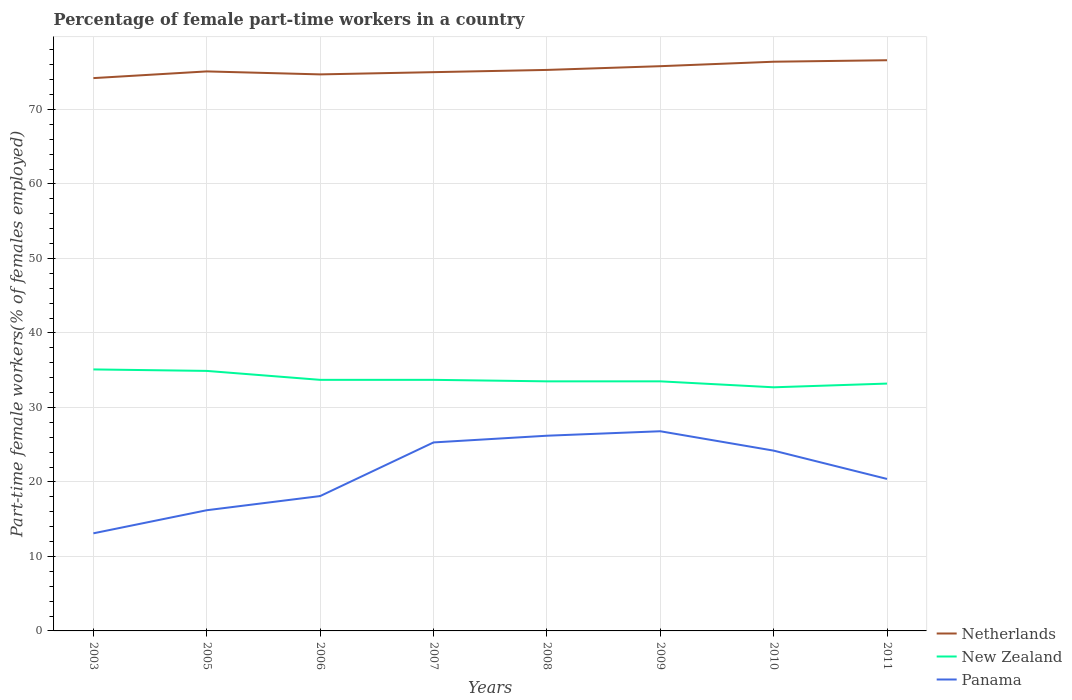Does the line corresponding to Panama intersect with the line corresponding to New Zealand?
Your answer should be very brief. No. Across all years, what is the maximum percentage of female part-time workers in New Zealand?
Keep it short and to the point. 32.7. What is the difference between the highest and the second highest percentage of female part-time workers in Netherlands?
Keep it short and to the point. 2.4. What is the difference between the highest and the lowest percentage of female part-time workers in Panama?
Make the answer very short. 4. Is the percentage of female part-time workers in New Zealand strictly greater than the percentage of female part-time workers in Netherlands over the years?
Offer a very short reply. Yes. How many lines are there?
Your answer should be very brief. 3. How many years are there in the graph?
Keep it short and to the point. 8. What is the difference between two consecutive major ticks on the Y-axis?
Offer a terse response. 10. Are the values on the major ticks of Y-axis written in scientific E-notation?
Your response must be concise. No. Where does the legend appear in the graph?
Your response must be concise. Bottom right. How many legend labels are there?
Offer a terse response. 3. How are the legend labels stacked?
Ensure brevity in your answer.  Vertical. What is the title of the graph?
Give a very brief answer. Percentage of female part-time workers in a country. Does "Myanmar" appear as one of the legend labels in the graph?
Provide a succinct answer. No. What is the label or title of the X-axis?
Provide a short and direct response. Years. What is the label or title of the Y-axis?
Keep it short and to the point. Part-time female workers(% of females employed). What is the Part-time female workers(% of females employed) of Netherlands in 2003?
Give a very brief answer. 74.2. What is the Part-time female workers(% of females employed) in New Zealand in 2003?
Offer a very short reply. 35.1. What is the Part-time female workers(% of females employed) in Panama in 2003?
Provide a short and direct response. 13.1. What is the Part-time female workers(% of females employed) in Netherlands in 2005?
Give a very brief answer. 75.1. What is the Part-time female workers(% of females employed) of New Zealand in 2005?
Make the answer very short. 34.9. What is the Part-time female workers(% of females employed) in Panama in 2005?
Your answer should be compact. 16.2. What is the Part-time female workers(% of females employed) of Netherlands in 2006?
Your response must be concise. 74.7. What is the Part-time female workers(% of females employed) of New Zealand in 2006?
Keep it short and to the point. 33.7. What is the Part-time female workers(% of females employed) in Panama in 2006?
Give a very brief answer. 18.1. What is the Part-time female workers(% of females employed) of New Zealand in 2007?
Ensure brevity in your answer.  33.7. What is the Part-time female workers(% of females employed) of Panama in 2007?
Provide a succinct answer. 25.3. What is the Part-time female workers(% of females employed) in Netherlands in 2008?
Keep it short and to the point. 75.3. What is the Part-time female workers(% of females employed) of New Zealand in 2008?
Give a very brief answer. 33.5. What is the Part-time female workers(% of females employed) of Panama in 2008?
Your answer should be compact. 26.2. What is the Part-time female workers(% of females employed) of Netherlands in 2009?
Offer a terse response. 75.8. What is the Part-time female workers(% of females employed) of New Zealand in 2009?
Provide a succinct answer. 33.5. What is the Part-time female workers(% of females employed) in Panama in 2009?
Make the answer very short. 26.8. What is the Part-time female workers(% of females employed) in Netherlands in 2010?
Offer a terse response. 76.4. What is the Part-time female workers(% of females employed) in New Zealand in 2010?
Your answer should be very brief. 32.7. What is the Part-time female workers(% of females employed) of Panama in 2010?
Provide a succinct answer. 24.2. What is the Part-time female workers(% of females employed) in Netherlands in 2011?
Ensure brevity in your answer.  76.6. What is the Part-time female workers(% of females employed) of New Zealand in 2011?
Keep it short and to the point. 33.2. What is the Part-time female workers(% of females employed) in Panama in 2011?
Provide a succinct answer. 20.4. Across all years, what is the maximum Part-time female workers(% of females employed) of Netherlands?
Your answer should be compact. 76.6. Across all years, what is the maximum Part-time female workers(% of females employed) of New Zealand?
Make the answer very short. 35.1. Across all years, what is the maximum Part-time female workers(% of females employed) in Panama?
Offer a terse response. 26.8. Across all years, what is the minimum Part-time female workers(% of females employed) of Netherlands?
Offer a very short reply. 74.2. Across all years, what is the minimum Part-time female workers(% of females employed) of New Zealand?
Your answer should be very brief. 32.7. Across all years, what is the minimum Part-time female workers(% of females employed) in Panama?
Provide a succinct answer. 13.1. What is the total Part-time female workers(% of females employed) in Netherlands in the graph?
Ensure brevity in your answer.  603.1. What is the total Part-time female workers(% of females employed) in New Zealand in the graph?
Provide a succinct answer. 270.3. What is the total Part-time female workers(% of females employed) in Panama in the graph?
Ensure brevity in your answer.  170.3. What is the difference between the Part-time female workers(% of females employed) of Netherlands in 2003 and that in 2005?
Your answer should be very brief. -0.9. What is the difference between the Part-time female workers(% of females employed) in New Zealand in 2003 and that in 2005?
Your answer should be compact. 0.2. What is the difference between the Part-time female workers(% of females employed) of Panama in 2003 and that in 2005?
Your response must be concise. -3.1. What is the difference between the Part-time female workers(% of females employed) in Panama in 2003 and that in 2006?
Keep it short and to the point. -5. What is the difference between the Part-time female workers(% of females employed) of Netherlands in 2003 and that in 2007?
Provide a short and direct response. -0.8. What is the difference between the Part-time female workers(% of females employed) in New Zealand in 2003 and that in 2007?
Offer a very short reply. 1.4. What is the difference between the Part-time female workers(% of females employed) in Panama in 2003 and that in 2008?
Keep it short and to the point. -13.1. What is the difference between the Part-time female workers(% of females employed) of Netherlands in 2003 and that in 2009?
Keep it short and to the point. -1.6. What is the difference between the Part-time female workers(% of females employed) in New Zealand in 2003 and that in 2009?
Your answer should be compact. 1.6. What is the difference between the Part-time female workers(% of females employed) in Panama in 2003 and that in 2009?
Your response must be concise. -13.7. What is the difference between the Part-time female workers(% of females employed) of Netherlands in 2003 and that in 2010?
Give a very brief answer. -2.2. What is the difference between the Part-time female workers(% of females employed) in New Zealand in 2003 and that in 2010?
Keep it short and to the point. 2.4. What is the difference between the Part-time female workers(% of females employed) of New Zealand in 2003 and that in 2011?
Give a very brief answer. 1.9. What is the difference between the Part-time female workers(% of females employed) in Panama in 2003 and that in 2011?
Keep it short and to the point. -7.3. What is the difference between the Part-time female workers(% of females employed) in Netherlands in 2005 and that in 2007?
Offer a very short reply. 0.1. What is the difference between the Part-time female workers(% of females employed) in Panama in 2005 and that in 2007?
Offer a very short reply. -9.1. What is the difference between the Part-time female workers(% of females employed) in New Zealand in 2005 and that in 2008?
Offer a very short reply. 1.4. What is the difference between the Part-time female workers(% of females employed) of Panama in 2005 and that in 2008?
Make the answer very short. -10. What is the difference between the Part-time female workers(% of females employed) in Netherlands in 2005 and that in 2009?
Make the answer very short. -0.7. What is the difference between the Part-time female workers(% of females employed) in Panama in 2005 and that in 2009?
Ensure brevity in your answer.  -10.6. What is the difference between the Part-time female workers(% of females employed) of New Zealand in 2005 and that in 2010?
Your answer should be very brief. 2.2. What is the difference between the Part-time female workers(% of females employed) of Panama in 2005 and that in 2010?
Offer a terse response. -8. What is the difference between the Part-time female workers(% of females employed) in Netherlands in 2005 and that in 2011?
Make the answer very short. -1.5. What is the difference between the Part-time female workers(% of females employed) in Panama in 2005 and that in 2011?
Make the answer very short. -4.2. What is the difference between the Part-time female workers(% of females employed) of Netherlands in 2006 and that in 2007?
Ensure brevity in your answer.  -0.3. What is the difference between the Part-time female workers(% of females employed) in New Zealand in 2006 and that in 2008?
Ensure brevity in your answer.  0.2. What is the difference between the Part-time female workers(% of females employed) in Panama in 2006 and that in 2009?
Give a very brief answer. -8.7. What is the difference between the Part-time female workers(% of females employed) of Panama in 2006 and that in 2010?
Your answer should be very brief. -6.1. What is the difference between the Part-time female workers(% of females employed) in Netherlands in 2006 and that in 2011?
Your answer should be compact. -1.9. What is the difference between the Part-time female workers(% of females employed) in New Zealand in 2006 and that in 2011?
Your answer should be compact. 0.5. What is the difference between the Part-time female workers(% of females employed) in Panama in 2006 and that in 2011?
Ensure brevity in your answer.  -2.3. What is the difference between the Part-time female workers(% of females employed) of Netherlands in 2007 and that in 2008?
Give a very brief answer. -0.3. What is the difference between the Part-time female workers(% of females employed) of Panama in 2007 and that in 2008?
Offer a terse response. -0.9. What is the difference between the Part-time female workers(% of females employed) of New Zealand in 2007 and that in 2009?
Offer a terse response. 0.2. What is the difference between the Part-time female workers(% of females employed) of Netherlands in 2007 and that in 2010?
Your answer should be compact. -1.4. What is the difference between the Part-time female workers(% of females employed) of Netherlands in 2008 and that in 2009?
Give a very brief answer. -0.5. What is the difference between the Part-time female workers(% of females employed) of New Zealand in 2008 and that in 2010?
Your answer should be compact. 0.8. What is the difference between the Part-time female workers(% of females employed) of Panama in 2008 and that in 2010?
Give a very brief answer. 2. What is the difference between the Part-time female workers(% of females employed) of Netherlands in 2008 and that in 2011?
Provide a succinct answer. -1.3. What is the difference between the Part-time female workers(% of females employed) in New Zealand in 2008 and that in 2011?
Keep it short and to the point. 0.3. What is the difference between the Part-time female workers(% of females employed) in New Zealand in 2009 and that in 2010?
Ensure brevity in your answer.  0.8. What is the difference between the Part-time female workers(% of females employed) in Panama in 2009 and that in 2010?
Give a very brief answer. 2.6. What is the difference between the Part-time female workers(% of females employed) in Netherlands in 2009 and that in 2011?
Provide a short and direct response. -0.8. What is the difference between the Part-time female workers(% of females employed) of Panama in 2009 and that in 2011?
Your answer should be very brief. 6.4. What is the difference between the Part-time female workers(% of females employed) of Netherlands in 2010 and that in 2011?
Provide a succinct answer. -0.2. What is the difference between the Part-time female workers(% of females employed) in New Zealand in 2010 and that in 2011?
Your answer should be compact. -0.5. What is the difference between the Part-time female workers(% of females employed) in Panama in 2010 and that in 2011?
Provide a succinct answer. 3.8. What is the difference between the Part-time female workers(% of females employed) in Netherlands in 2003 and the Part-time female workers(% of females employed) in New Zealand in 2005?
Ensure brevity in your answer.  39.3. What is the difference between the Part-time female workers(% of females employed) of Netherlands in 2003 and the Part-time female workers(% of females employed) of Panama in 2005?
Provide a succinct answer. 58. What is the difference between the Part-time female workers(% of females employed) in New Zealand in 2003 and the Part-time female workers(% of females employed) in Panama in 2005?
Provide a short and direct response. 18.9. What is the difference between the Part-time female workers(% of females employed) in Netherlands in 2003 and the Part-time female workers(% of females employed) in New Zealand in 2006?
Your answer should be compact. 40.5. What is the difference between the Part-time female workers(% of females employed) in Netherlands in 2003 and the Part-time female workers(% of females employed) in Panama in 2006?
Keep it short and to the point. 56.1. What is the difference between the Part-time female workers(% of females employed) in Netherlands in 2003 and the Part-time female workers(% of females employed) in New Zealand in 2007?
Your answer should be very brief. 40.5. What is the difference between the Part-time female workers(% of females employed) in Netherlands in 2003 and the Part-time female workers(% of females employed) in Panama in 2007?
Ensure brevity in your answer.  48.9. What is the difference between the Part-time female workers(% of females employed) of Netherlands in 2003 and the Part-time female workers(% of females employed) of New Zealand in 2008?
Keep it short and to the point. 40.7. What is the difference between the Part-time female workers(% of females employed) in Netherlands in 2003 and the Part-time female workers(% of females employed) in Panama in 2008?
Your answer should be compact. 48. What is the difference between the Part-time female workers(% of females employed) of Netherlands in 2003 and the Part-time female workers(% of females employed) of New Zealand in 2009?
Keep it short and to the point. 40.7. What is the difference between the Part-time female workers(% of females employed) in Netherlands in 2003 and the Part-time female workers(% of females employed) in Panama in 2009?
Give a very brief answer. 47.4. What is the difference between the Part-time female workers(% of females employed) of New Zealand in 2003 and the Part-time female workers(% of females employed) of Panama in 2009?
Your answer should be compact. 8.3. What is the difference between the Part-time female workers(% of females employed) in Netherlands in 2003 and the Part-time female workers(% of females employed) in New Zealand in 2010?
Offer a terse response. 41.5. What is the difference between the Part-time female workers(% of females employed) in Netherlands in 2003 and the Part-time female workers(% of females employed) in Panama in 2011?
Provide a succinct answer. 53.8. What is the difference between the Part-time female workers(% of females employed) in New Zealand in 2003 and the Part-time female workers(% of females employed) in Panama in 2011?
Provide a succinct answer. 14.7. What is the difference between the Part-time female workers(% of females employed) of Netherlands in 2005 and the Part-time female workers(% of females employed) of New Zealand in 2006?
Give a very brief answer. 41.4. What is the difference between the Part-time female workers(% of females employed) of Netherlands in 2005 and the Part-time female workers(% of females employed) of New Zealand in 2007?
Ensure brevity in your answer.  41.4. What is the difference between the Part-time female workers(% of females employed) of Netherlands in 2005 and the Part-time female workers(% of females employed) of Panama in 2007?
Your response must be concise. 49.8. What is the difference between the Part-time female workers(% of females employed) in Netherlands in 2005 and the Part-time female workers(% of females employed) in New Zealand in 2008?
Offer a very short reply. 41.6. What is the difference between the Part-time female workers(% of females employed) in Netherlands in 2005 and the Part-time female workers(% of females employed) in Panama in 2008?
Give a very brief answer. 48.9. What is the difference between the Part-time female workers(% of females employed) of New Zealand in 2005 and the Part-time female workers(% of females employed) of Panama in 2008?
Ensure brevity in your answer.  8.7. What is the difference between the Part-time female workers(% of females employed) of Netherlands in 2005 and the Part-time female workers(% of females employed) of New Zealand in 2009?
Provide a succinct answer. 41.6. What is the difference between the Part-time female workers(% of females employed) in Netherlands in 2005 and the Part-time female workers(% of females employed) in Panama in 2009?
Make the answer very short. 48.3. What is the difference between the Part-time female workers(% of females employed) in New Zealand in 2005 and the Part-time female workers(% of females employed) in Panama in 2009?
Provide a short and direct response. 8.1. What is the difference between the Part-time female workers(% of females employed) of Netherlands in 2005 and the Part-time female workers(% of females employed) of New Zealand in 2010?
Your answer should be very brief. 42.4. What is the difference between the Part-time female workers(% of females employed) in Netherlands in 2005 and the Part-time female workers(% of females employed) in Panama in 2010?
Make the answer very short. 50.9. What is the difference between the Part-time female workers(% of females employed) of New Zealand in 2005 and the Part-time female workers(% of females employed) of Panama in 2010?
Keep it short and to the point. 10.7. What is the difference between the Part-time female workers(% of females employed) in Netherlands in 2005 and the Part-time female workers(% of females employed) in New Zealand in 2011?
Keep it short and to the point. 41.9. What is the difference between the Part-time female workers(% of females employed) of Netherlands in 2005 and the Part-time female workers(% of females employed) of Panama in 2011?
Your answer should be very brief. 54.7. What is the difference between the Part-time female workers(% of females employed) of New Zealand in 2005 and the Part-time female workers(% of females employed) of Panama in 2011?
Offer a terse response. 14.5. What is the difference between the Part-time female workers(% of females employed) in Netherlands in 2006 and the Part-time female workers(% of females employed) in New Zealand in 2007?
Provide a short and direct response. 41. What is the difference between the Part-time female workers(% of females employed) of Netherlands in 2006 and the Part-time female workers(% of females employed) of Panama in 2007?
Your response must be concise. 49.4. What is the difference between the Part-time female workers(% of females employed) in New Zealand in 2006 and the Part-time female workers(% of females employed) in Panama in 2007?
Ensure brevity in your answer.  8.4. What is the difference between the Part-time female workers(% of females employed) in Netherlands in 2006 and the Part-time female workers(% of females employed) in New Zealand in 2008?
Offer a very short reply. 41.2. What is the difference between the Part-time female workers(% of females employed) of Netherlands in 2006 and the Part-time female workers(% of females employed) of Panama in 2008?
Your answer should be compact. 48.5. What is the difference between the Part-time female workers(% of females employed) of Netherlands in 2006 and the Part-time female workers(% of females employed) of New Zealand in 2009?
Provide a short and direct response. 41.2. What is the difference between the Part-time female workers(% of females employed) in Netherlands in 2006 and the Part-time female workers(% of females employed) in Panama in 2009?
Provide a short and direct response. 47.9. What is the difference between the Part-time female workers(% of females employed) in New Zealand in 2006 and the Part-time female workers(% of females employed) in Panama in 2009?
Keep it short and to the point. 6.9. What is the difference between the Part-time female workers(% of females employed) in Netherlands in 2006 and the Part-time female workers(% of females employed) in Panama in 2010?
Provide a short and direct response. 50.5. What is the difference between the Part-time female workers(% of females employed) of Netherlands in 2006 and the Part-time female workers(% of females employed) of New Zealand in 2011?
Give a very brief answer. 41.5. What is the difference between the Part-time female workers(% of females employed) in Netherlands in 2006 and the Part-time female workers(% of females employed) in Panama in 2011?
Your response must be concise. 54.3. What is the difference between the Part-time female workers(% of females employed) of Netherlands in 2007 and the Part-time female workers(% of females employed) of New Zealand in 2008?
Provide a short and direct response. 41.5. What is the difference between the Part-time female workers(% of females employed) of Netherlands in 2007 and the Part-time female workers(% of females employed) of Panama in 2008?
Ensure brevity in your answer.  48.8. What is the difference between the Part-time female workers(% of females employed) in Netherlands in 2007 and the Part-time female workers(% of females employed) in New Zealand in 2009?
Make the answer very short. 41.5. What is the difference between the Part-time female workers(% of females employed) of Netherlands in 2007 and the Part-time female workers(% of females employed) of Panama in 2009?
Keep it short and to the point. 48.2. What is the difference between the Part-time female workers(% of females employed) of New Zealand in 2007 and the Part-time female workers(% of females employed) of Panama in 2009?
Your answer should be compact. 6.9. What is the difference between the Part-time female workers(% of females employed) of Netherlands in 2007 and the Part-time female workers(% of females employed) of New Zealand in 2010?
Your answer should be very brief. 42.3. What is the difference between the Part-time female workers(% of females employed) in Netherlands in 2007 and the Part-time female workers(% of females employed) in Panama in 2010?
Your answer should be compact. 50.8. What is the difference between the Part-time female workers(% of females employed) of New Zealand in 2007 and the Part-time female workers(% of females employed) of Panama in 2010?
Ensure brevity in your answer.  9.5. What is the difference between the Part-time female workers(% of females employed) of Netherlands in 2007 and the Part-time female workers(% of females employed) of New Zealand in 2011?
Give a very brief answer. 41.8. What is the difference between the Part-time female workers(% of females employed) of Netherlands in 2007 and the Part-time female workers(% of females employed) of Panama in 2011?
Your answer should be compact. 54.6. What is the difference between the Part-time female workers(% of females employed) of New Zealand in 2007 and the Part-time female workers(% of females employed) of Panama in 2011?
Provide a short and direct response. 13.3. What is the difference between the Part-time female workers(% of females employed) of Netherlands in 2008 and the Part-time female workers(% of females employed) of New Zealand in 2009?
Make the answer very short. 41.8. What is the difference between the Part-time female workers(% of females employed) of Netherlands in 2008 and the Part-time female workers(% of females employed) of Panama in 2009?
Your answer should be very brief. 48.5. What is the difference between the Part-time female workers(% of females employed) in Netherlands in 2008 and the Part-time female workers(% of females employed) in New Zealand in 2010?
Ensure brevity in your answer.  42.6. What is the difference between the Part-time female workers(% of females employed) in Netherlands in 2008 and the Part-time female workers(% of females employed) in Panama in 2010?
Your answer should be compact. 51.1. What is the difference between the Part-time female workers(% of females employed) of New Zealand in 2008 and the Part-time female workers(% of females employed) of Panama in 2010?
Offer a very short reply. 9.3. What is the difference between the Part-time female workers(% of females employed) of Netherlands in 2008 and the Part-time female workers(% of females employed) of New Zealand in 2011?
Give a very brief answer. 42.1. What is the difference between the Part-time female workers(% of females employed) in Netherlands in 2008 and the Part-time female workers(% of females employed) in Panama in 2011?
Offer a terse response. 54.9. What is the difference between the Part-time female workers(% of females employed) of Netherlands in 2009 and the Part-time female workers(% of females employed) of New Zealand in 2010?
Ensure brevity in your answer.  43.1. What is the difference between the Part-time female workers(% of females employed) in Netherlands in 2009 and the Part-time female workers(% of females employed) in Panama in 2010?
Ensure brevity in your answer.  51.6. What is the difference between the Part-time female workers(% of females employed) in Netherlands in 2009 and the Part-time female workers(% of females employed) in New Zealand in 2011?
Ensure brevity in your answer.  42.6. What is the difference between the Part-time female workers(% of females employed) of Netherlands in 2009 and the Part-time female workers(% of females employed) of Panama in 2011?
Give a very brief answer. 55.4. What is the difference between the Part-time female workers(% of females employed) of New Zealand in 2009 and the Part-time female workers(% of females employed) of Panama in 2011?
Your answer should be compact. 13.1. What is the difference between the Part-time female workers(% of females employed) in Netherlands in 2010 and the Part-time female workers(% of females employed) in New Zealand in 2011?
Provide a succinct answer. 43.2. What is the difference between the Part-time female workers(% of females employed) in New Zealand in 2010 and the Part-time female workers(% of females employed) in Panama in 2011?
Ensure brevity in your answer.  12.3. What is the average Part-time female workers(% of females employed) in Netherlands per year?
Your answer should be compact. 75.39. What is the average Part-time female workers(% of females employed) of New Zealand per year?
Your response must be concise. 33.79. What is the average Part-time female workers(% of females employed) in Panama per year?
Your response must be concise. 21.29. In the year 2003, what is the difference between the Part-time female workers(% of females employed) in Netherlands and Part-time female workers(% of females employed) in New Zealand?
Offer a terse response. 39.1. In the year 2003, what is the difference between the Part-time female workers(% of females employed) of Netherlands and Part-time female workers(% of females employed) of Panama?
Your answer should be very brief. 61.1. In the year 2003, what is the difference between the Part-time female workers(% of females employed) of New Zealand and Part-time female workers(% of females employed) of Panama?
Make the answer very short. 22. In the year 2005, what is the difference between the Part-time female workers(% of females employed) of Netherlands and Part-time female workers(% of females employed) of New Zealand?
Your response must be concise. 40.2. In the year 2005, what is the difference between the Part-time female workers(% of females employed) in Netherlands and Part-time female workers(% of females employed) in Panama?
Provide a short and direct response. 58.9. In the year 2005, what is the difference between the Part-time female workers(% of females employed) of New Zealand and Part-time female workers(% of females employed) of Panama?
Your answer should be compact. 18.7. In the year 2006, what is the difference between the Part-time female workers(% of females employed) of Netherlands and Part-time female workers(% of females employed) of Panama?
Provide a succinct answer. 56.6. In the year 2007, what is the difference between the Part-time female workers(% of females employed) of Netherlands and Part-time female workers(% of females employed) of New Zealand?
Keep it short and to the point. 41.3. In the year 2007, what is the difference between the Part-time female workers(% of females employed) in Netherlands and Part-time female workers(% of females employed) in Panama?
Provide a short and direct response. 49.7. In the year 2007, what is the difference between the Part-time female workers(% of females employed) of New Zealand and Part-time female workers(% of females employed) of Panama?
Give a very brief answer. 8.4. In the year 2008, what is the difference between the Part-time female workers(% of females employed) in Netherlands and Part-time female workers(% of females employed) in New Zealand?
Make the answer very short. 41.8. In the year 2008, what is the difference between the Part-time female workers(% of females employed) of Netherlands and Part-time female workers(% of females employed) of Panama?
Keep it short and to the point. 49.1. In the year 2008, what is the difference between the Part-time female workers(% of females employed) in New Zealand and Part-time female workers(% of females employed) in Panama?
Your answer should be compact. 7.3. In the year 2009, what is the difference between the Part-time female workers(% of females employed) in Netherlands and Part-time female workers(% of females employed) in New Zealand?
Give a very brief answer. 42.3. In the year 2009, what is the difference between the Part-time female workers(% of females employed) in New Zealand and Part-time female workers(% of females employed) in Panama?
Keep it short and to the point. 6.7. In the year 2010, what is the difference between the Part-time female workers(% of females employed) of Netherlands and Part-time female workers(% of females employed) of New Zealand?
Ensure brevity in your answer.  43.7. In the year 2010, what is the difference between the Part-time female workers(% of females employed) in Netherlands and Part-time female workers(% of females employed) in Panama?
Offer a terse response. 52.2. In the year 2010, what is the difference between the Part-time female workers(% of females employed) in New Zealand and Part-time female workers(% of females employed) in Panama?
Provide a short and direct response. 8.5. In the year 2011, what is the difference between the Part-time female workers(% of females employed) of Netherlands and Part-time female workers(% of females employed) of New Zealand?
Give a very brief answer. 43.4. In the year 2011, what is the difference between the Part-time female workers(% of females employed) in Netherlands and Part-time female workers(% of females employed) in Panama?
Your answer should be very brief. 56.2. In the year 2011, what is the difference between the Part-time female workers(% of females employed) of New Zealand and Part-time female workers(% of females employed) of Panama?
Give a very brief answer. 12.8. What is the ratio of the Part-time female workers(% of females employed) in Netherlands in 2003 to that in 2005?
Keep it short and to the point. 0.99. What is the ratio of the Part-time female workers(% of females employed) of New Zealand in 2003 to that in 2005?
Make the answer very short. 1.01. What is the ratio of the Part-time female workers(% of females employed) of Panama in 2003 to that in 2005?
Provide a short and direct response. 0.81. What is the ratio of the Part-time female workers(% of females employed) in New Zealand in 2003 to that in 2006?
Offer a terse response. 1.04. What is the ratio of the Part-time female workers(% of females employed) of Panama in 2003 to that in 2006?
Make the answer very short. 0.72. What is the ratio of the Part-time female workers(% of females employed) in Netherlands in 2003 to that in 2007?
Offer a terse response. 0.99. What is the ratio of the Part-time female workers(% of females employed) in New Zealand in 2003 to that in 2007?
Give a very brief answer. 1.04. What is the ratio of the Part-time female workers(% of females employed) in Panama in 2003 to that in 2007?
Offer a very short reply. 0.52. What is the ratio of the Part-time female workers(% of females employed) of Netherlands in 2003 to that in 2008?
Give a very brief answer. 0.99. What is the ratio of the Part-time female workers(% of females employed) of New Zealand in 2003 to that in 2008?
Make the answer very short. 1.05. What is the ratio of the Part-time female workers(% of females employed) of Netherlands in 2003 to that in 2009?
Keep it short and to the point. 0.98. What is the ratio of the Part-time female workers(% of females employed) of New Zealand in 2003 to that in 2009?
Your answer should be compact. 1.05. What is the ratio of the Part-time female workers(% of females employed) of Panama in 2003 to that in 2009?
Make the answer very short. 0.49. What is the ratio of the Part-time female workers(% of females employed) in Netherlands in 2003 to that in 2010?
Your answer should be compact. 0.97. What is the ratio of the Part-time female workers(% of females employed) of New Zealand in 2003 to that in 2010?
Your answer should be very brief. 1.07. What is the ratio of the Part-time female workers(% of females employed) in Panama in 2003 to that in 2010?
Give a very brief answer. 0.54. What is the ratio of the Part-time female workers(% of females employed) in Netherlands in 2003 to that in 2011?
Provide a succinct answer. 0.97. What is the ratio of the Part-time female workers(% of females employed) in New Zealand in 2003 to that in 2011?
Make the answer very short. 1.06. What is the ratio of the Part-time female workers(% of females employed) of Panama in 2003 to that in 2011?
Provide a succinct answer. 0.64. What is the ratio of the Part-time female workers(% of females employed) in Netherlands in 2005 to that in 2006?
Your answer should be very brief. 1.01. What is the ratio of the Part-time female workers(% of females employed) in New Zealand in 2005 to that in 2006?
Give a very brief answer. 1.04. What is the ratio of the Part-time female workers(% of females employed) in Panama in 2005 to that in 2006?
Keep it short and to the point. 0.9. What is the ratio of the Part-time female workers(% of females employed) of Netherlands in 2005 to that in 2007?
Give a very brief answer. 1. What is the ratio of the Part-time female workers(% of females employed) of New Zealand in 2005 to that in 2007?
Your answer should be compact. 1.04. What is the ratio of the Part-time female workers(% of females employed) of Panama in 2005 to that in 2007?
Ensure brevity in your answer.  0.64. What is the ratio of the Part-time female workers(% of females employed) in New Zealand in 2005 to that in 2008?
Ensure brevity in your answer.  1.04. What is the ratio of the Part-time female workers(% of females employed) of Panama in 2005 to that in 2008?
Offer a very short reply. 0.62. What is the ratio of the Part-time female workers(% of females employed) of Netherlands in 2005 to that in 2009?
Your response must be concise. 0.99. What is the ratio of the Part-time female workers(% of females employed) in New Zealand in 2005 to that in 2009?
Make the answer very short. 1.04. What is the ratio of the Part-time female workers(% of females employed) in Panama in 2005 to that in 2009?
Offer a very short reply. 0.6. What is the ratio of the Part-time female workers(% of females employed) in New Zealand in 2005 to that in 2010?
Provide a short and direct response. 1.07. What is the ratio of the Part-time female workers(% of females employed) of Panama in 2005 to that in 2010?
Ensure brevity in your answer.  0.67. What is the ratio of the Part-time female workers(% of females employed) in Netherlands in 2005 to that in 2011?
Your response must be concise. 0.98. What is the ratio of the Part-time female workers(% of females employed) of New Zealand in 2005 to that in 2011?
Ensure brevity in your answer.  1.05. What is the ratio of the Part-time female workers(% of females employed) of Panama in 2005 to that in 2011?
Make the answer very short. 0.79. What is the ratio of the Part-time female workers(% of females employed) of Panama in 2006 to that in 2007?
Offer a terse response. 0.72. What is the ratio of the Part-time female workers(% of females employed) of Panama in 2006 to that in 2008?
Your answer should be very brief. 0.69. What is the ratio of the Part-time female workers(% of females employed) in Netherlands in 2006 to that in 2009?
Make the answer very short. 0.99. What is the ratio of the Part-time female workers(% of females employed) in New Zealand in 2006 to that in 2009?
Your response must be concise. 1.01. What is the ratio of the Part-time female workers(% of females employed) in Panama in 2006 to that in 2009?
Offer a very short reply. 0.68. What is the ratio of the Part-time female workers(% of females employed) of Netherlands in 2006 to that in 2010?
Offer a terse response. 0.98. What is the ratio of the Part-time female workers(% of females employed) of New Zealand in 2006 to that in 2010?
Offer a terse response. 1.03. What is the ratio of the Part-time female workers(% of females employed) in Panama in 2006 to that in 2010?
Provide a short and direct response. 0.75. What is the ratio of the Part-time female workers(% of females employed) of Netherlands in 2006 to that in 2011?
Keep it short and to the point. 0.98. What is the ratio of the Part-time female workers(% of females employed) in New Zealand in 2006 to that in 2011?
Offer a terse response. 1.02. What is the ratio of the Part-time female workers(% of females employed) in Panama in 2006 to that in 2011?
Your answer should be compact. 0.89. What is the ratio of the Part-time female workers(% of females employed) of New Zealand in 2007 to that in 2008?
Your response must be concise. 1.01. What is the ratio of the Part-time female workers(% of females employed) of Panama in 2007 to that in 2008?
Give a very brief answer. 0.97. What is the ratio of the Part-time female workers(% of females employed) of Netherlands in 2007 to that in 2009?
Your answer should be very brief. 0.99. What is the ratio of the Part-time female workers(% of females employed) in New Zealand in 2007 to that in 2009?
Offer a very short reply. 1.01. What is the ratio of the Part-time female workers(% of females employed) in Panama in 2007 to that in 2009?
Your answer should be very brief. 0.94. What is the ratio of the Part-time female workers(% of females employed) of Netherlands in 2007 to that in 2010?
Your answer should be very brief. 0.98. What is the ratio of the Part-time female workers(% of females employed) of New Zealand in 2007 to that in 2010?
Offer a terse response. 1.03. What is the ratio of the Part-time female workers(% of females employed) of Panama in 2007 to that in 2010?
Your response must be concise. 1.05. What is the ratio of the Part-time female workers(% of females employed) in Netherlands in 2007 to that in 2011?
Provide a short and direct response. 0.98. What is the ratio of the Part-time female workers(% of females employed) in New Zealand in 2007 to that in 2011?
Your answer should be very brief. 1.02. What is the ratio of the Part-time female workers(% of females employed) of Panama in 2007 to that in 2011?
Your response must be concise. 1.24. What is the ratio of the Part-time female workers(% of females employed) in Panama in 2008 to that in 2009?
Your answer should be compact. 0.98. What is the ratio of the Part-time female workers(% of females employed) of Netherlands in 2008 to that in 2010?
Your answer should be very brief. 0.99. What is the ratio of the Part-time female workers(% of females employed) in New Zealand in 2008 to that in 2010?
Provide a short and direct response. 1.02. What is the ratio of the Part-time female workers(% of females employed) of Panama in 2008 to that in 2010?
Provide a succinct answer. 1.08. What is the ratio of the Part-time female workers(% of females employed) in New Zealand in 2008 to that in 2011?
Your answer should be compact. 1.01. What is the ratio of the Part-time female workers(% of females employed) of Panama in 2008 to that in 2011?
Ensure brevity in your answer.  1.28. What is the ratio of the Part-time female workers(% of females employed) of New Zealand in 2009 to that in 2010?
Offer a terse response. 1.02. What is the ratio of the Part-time female workers(% of females employed) of Panama in 2009 to that in 2010?
Keep it short and to the point. 1.11. What is the ratio of the Part-time female workers(% of females employed) in Netherlands in 2009 to that in 2011?
Give a very brief answer. 0.99. What is the ratio of the Part-time female workers(% of females employed) of Panama in 2009 to that in 2011?
Your answer should be very brief. 1.31. What is the ratio of the Part-time female workers(% of females employed) of Netherlands in 2010 to that in 2011?
Keep it short and to the point. 1. What is the ratio of the Part-time female workers(% of females employed) of New Zealand in 2010 to that in 2011?
Ensure brevity in your answer.  0.98. What is the ratio of the Part-time female workers(% of females employed) of Panama in 2010 to that in 2011?
Offer a very short reply. 1.19. What is the difference between the highest and the lowest Part-time female workers(% of females employed) of Panama?
Offer a terse response. 13.7. 